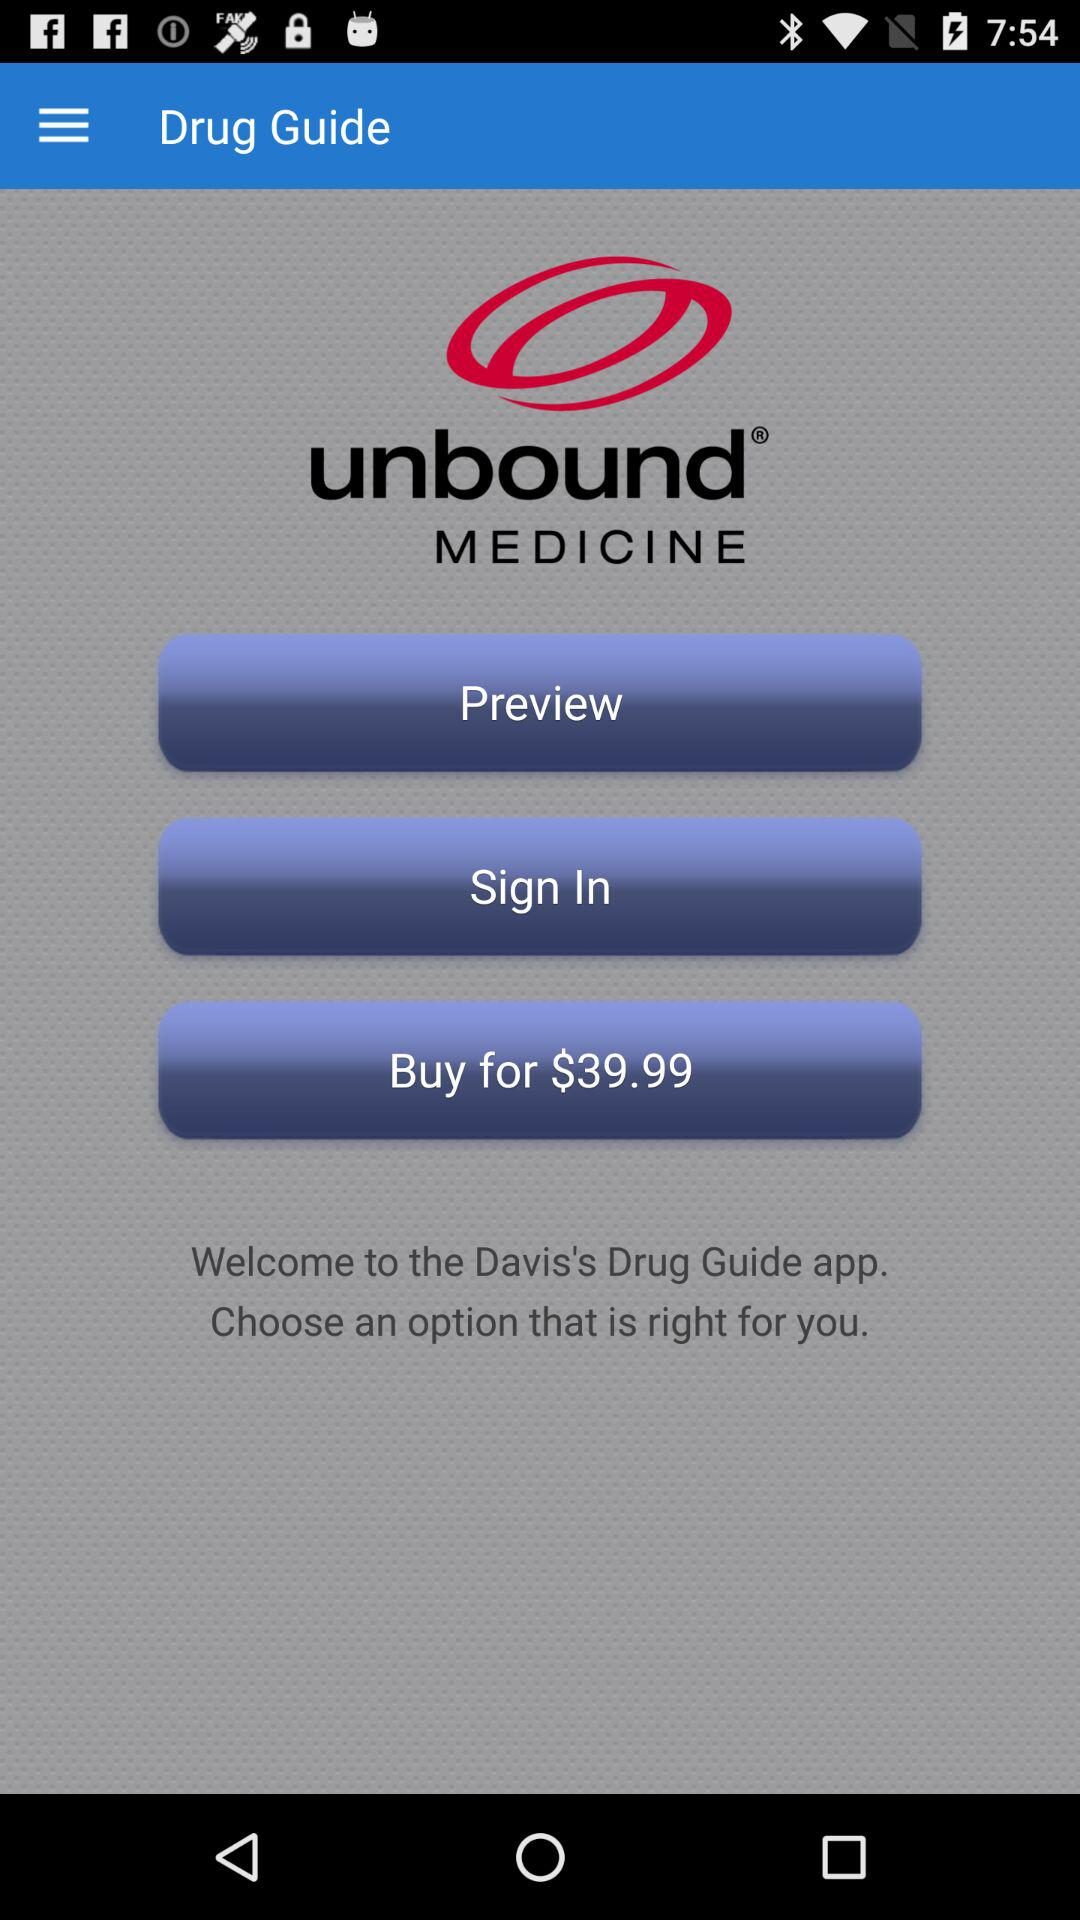What is the buying price? The buying price is $39.99. 